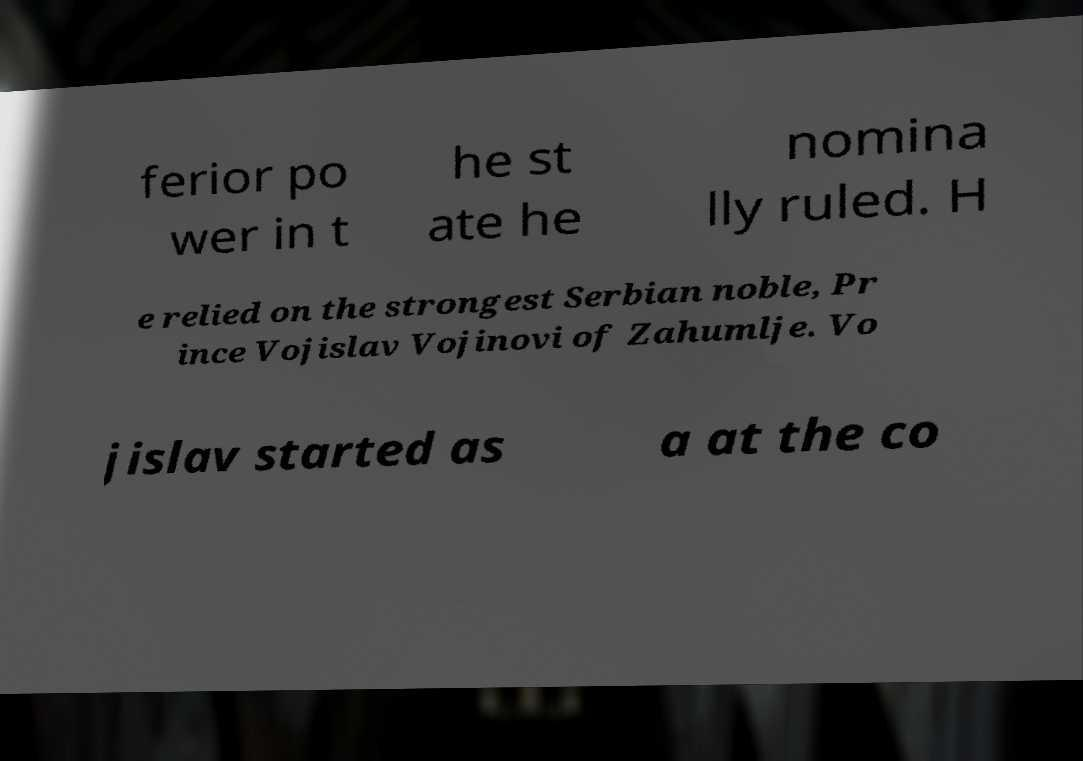I need the written content from this picture converted into text. Can you do that? ferior po wer in t he st ate he nomina lly ruled. H e relied on the strongest Serbian noble, Pr ince Vojislav Vojinovi of Zahumlje. Vo jislav started as a at the co 